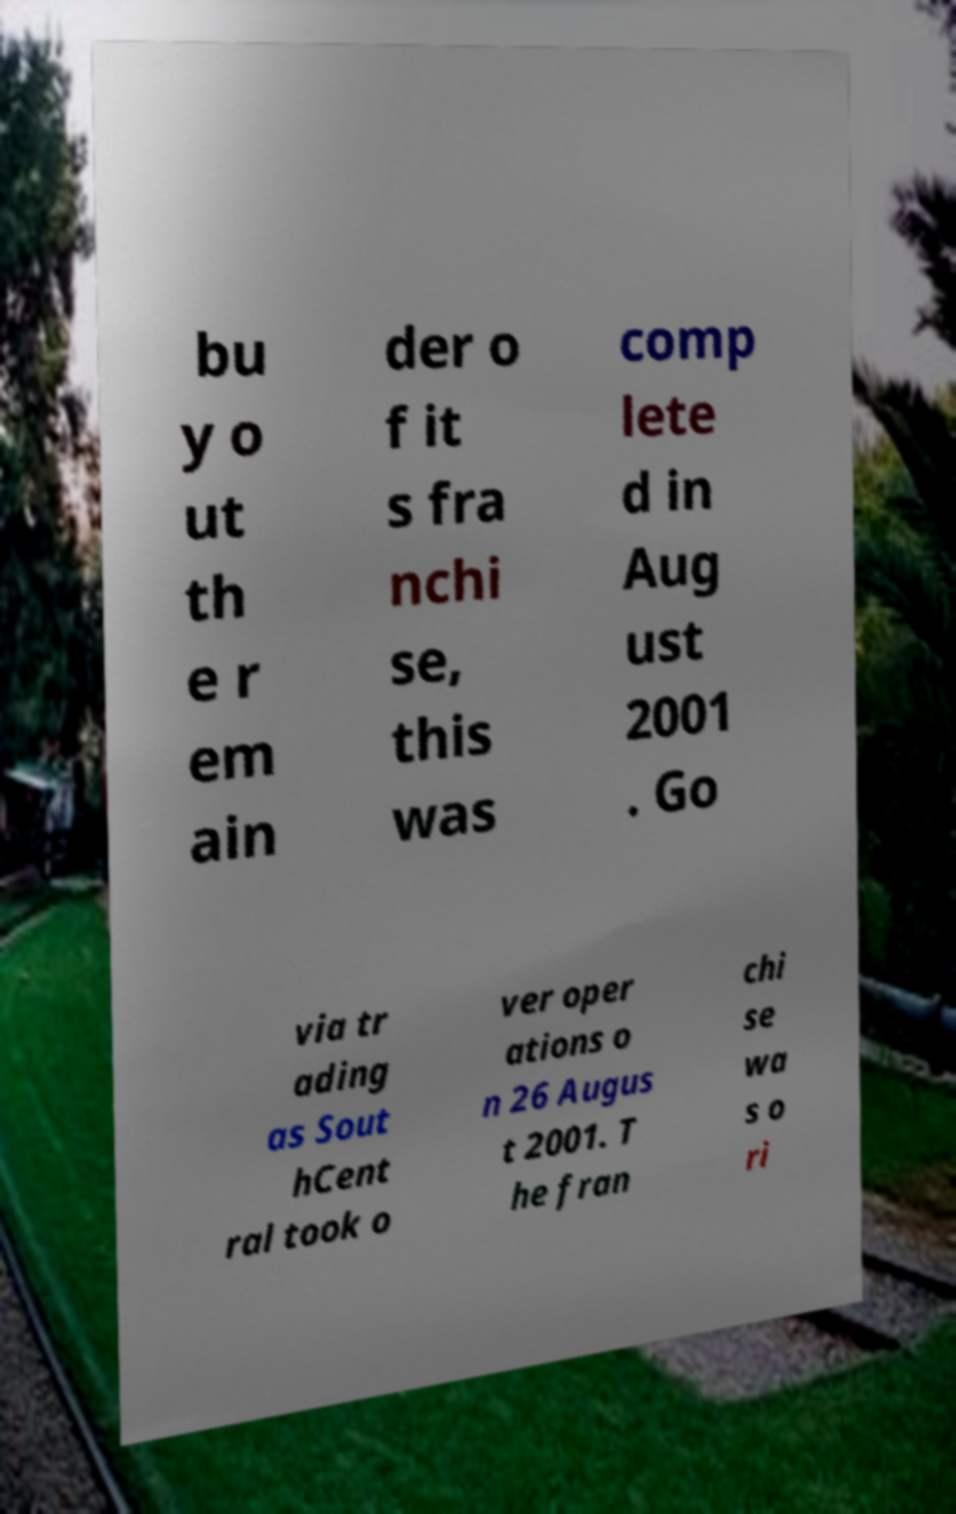Can you read and provide the text displayed in the image?This photo seems to have some interesting text. Can you extract and type it out for me? bu y o ut th e r em ain der o f it s fra nchi se, this was comp lete d in Aug ust 2001 . Go via tr ading as Sout hCent ral took o ver oper ations o n 26 Augus t 2001. T he fran chi se wa s o ri 